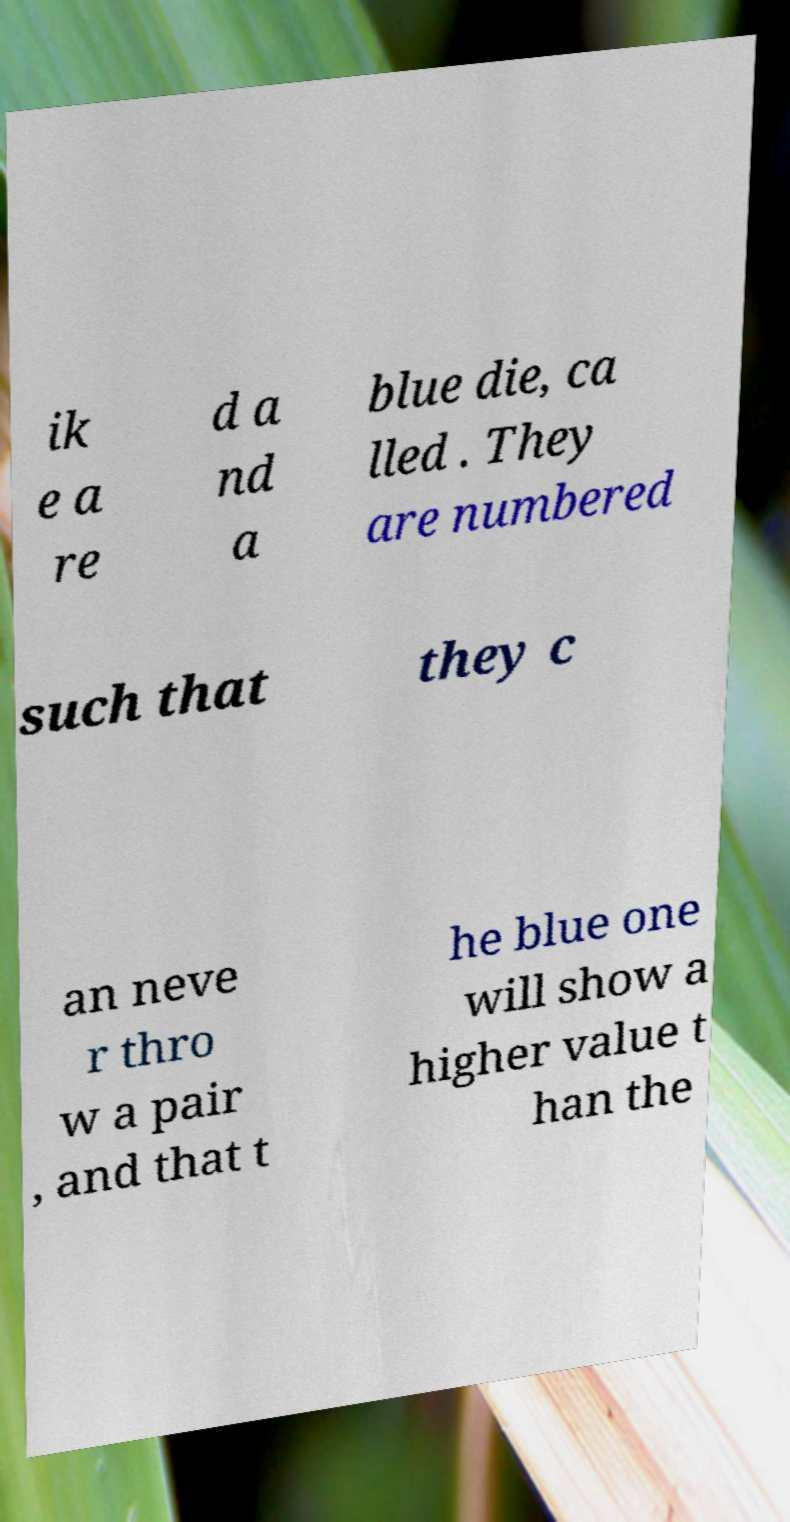Please read and relay the text visible in this image. What does it say? ik e a re d a nd a blue die, ca lled . They are numbered such that they c an neve r thro w a pair , and that t he blue one will show a higher value t han the 